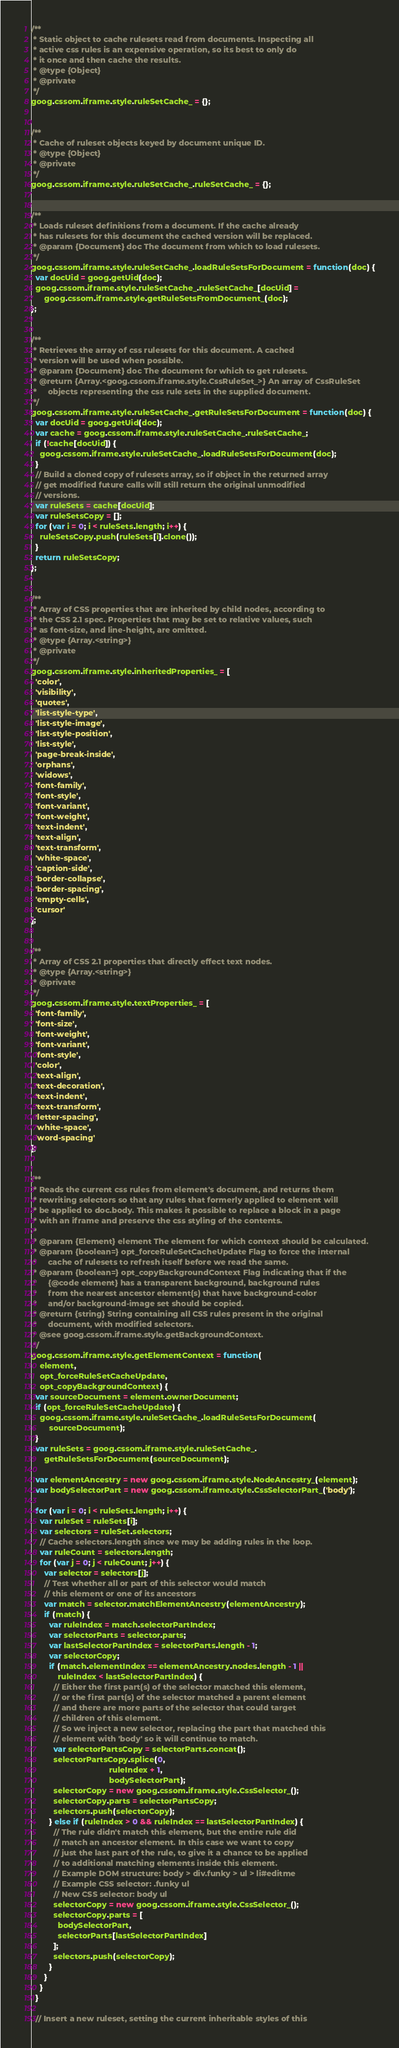<code> <loc_0><loc_0><loc_500><loc_500><_JavaScript_>
/**
 * Static object to cache rulesets read from documents. Inspecting all
 * active css rules is an expensive operation, so its best to only do
 * it once and then cache the results.
 * @type {Object}
 * @private
 */
goog.cssom.iframe.style.ruleSetCache_ = {};


/**
 * Cache of ruleset objects keyed by document unique ID.
 * @type {Object}
 * @private
 */
goog.cssom.iframe.style.ruleSetCache_.ruleSetCache_ = {};


/**
 * Loads ruleset definitions from a document. If the cache already
 * has rulesets for this document the cached version will be replaced.
 * @param {Document} doc The document from which to load rulesets.
 */
goog.cssom.iframe.style.ruleSetCache_.loadRuleSetsForDocument = function(doc) {
  var docUid = goog.getUid(doc);
  goog.cssom.iframe.style.ruleSetCache_.ruleSetCache_[docUid] =
      goog.cssom.iframe.style.getRuleSetsFromDocument_(doc);
};


/**
 * Retrieves the array of css rulesets for this document. A cached
 * version will be used when possible.
 * @param {Document} doc The document for which to get rulesets.
 * @return {Array.<goog.cssom.iframe.style.CssRuleSet_>} An array of CssRuleSet
 *     objects representing the css rule sets in the supplied document.
 */
goog.cssom.iframe.style.ruleSetCache_.getRuleSetsForDocument = function(doc) {
  var docUid = goog.getUid(doc);
  var cache = goog.cssom.iframe.style.ruleSetCache_.ruleSetCache_;
  if (!cache[docUid]) {
    goog.cssom.iframe.style.ruleSetCache_.loadRuleSetsForDocument(doc);
  }
  // Build a cloned copy of rulesets array, so if object in the returned array
  // get modified future calls will still return the original unmodified
  // versions.
  var ruleSets = cache[docUid];
  var ruleSetsCopy = [];
  for (var i = 0; i < ruleSets.length; i++) {
    ruleSetsCopy.push(ruleSets[i].clone());
  }
  return ruleSetsCopy;
};


/**
 * Array of CSS properties that are inherited by child nodes, according to
 * the CSS 2.1 spec. Properties that may be set to relative values, such
 * as font-size, and line-height, are omitted.
 * @type {Array.<string>}
 * @private
 */
goog.cssom.iframe.style.inheritedProperties_ = [
  'color',
  'visibility',
  'quotes',
  'list-style-type',
  'list-style-image',
  'list-style-position',
  'list-style',
  'page-break-inside',
  'orphans',
  'widows',
  'font-family',
  'font-style',
  'font-variant',
  'font-weight',
  'text-indent',
  'text-align',
  'text-transform',
  'white-space',
  'caption-side',
  'border-collapse',
  'border-spacing',
  'empty-cells',
  'cursor'
];


/**
 * Array of CSS 2.1 properties that directly effect text nodes.
 * @type {Array.<string>}
 * @private
 */
goog.cssom.iframe.style.textProperties_ = [
  'font-family',
  'font-size',
  'font-weight',
  'font-variant',
  'font-style',
  'color',
  'text-align',
  'text-decoration',
  'text-indent',
  'text-transform',
  'letter-spacing',
  'white-space',
  'word-spacing'
];


/**
 * Reads the current css rules from element's document, and returns them
 * rewriting selectors so that any rules that formerly applied to element will
 * be applied to doc.body. This makes it possible to replace a block in a page
 * with an iframe and preserve the css styling of the contents.
 *
 * @param {Element} element The element for which context should be calculated.
 * @param {boolean=} opt_forceRuleSetCacheUpdate Flag to force the internal
 *     cache of rulesets to refresh itself before we read the same.
 * @param {boolean=} opt_copyBackgroundContext Flag indicating that if the
 *     {@code element} has a transparent background, background rules
 *     from the nearest ancestor element(s) that have background-color
 *     and/or background-image set should be copied.
 * @return {string} String containing all CSS rules present in the original
 *     document, with modified selectors.
 * @see goog.cssom.iframe.style.getBackgroundContext.
 */
goog.cssom.iframe.style.getElementContext = function(
    element,
    opt_forceRuleSetCacheUpdate,
    opt_copyBackgroundContext) {
  var sourceDocument = element.ownerDocument;
  if (opt_forceRuleSetCacheUpdate) {
    goog.cssom.iframe.style.ruleSetCache_.loadRuleSetsForDocument(
        sourceDocument);
  }
  var ruleSets = goog.cssom.iframe.style.ruleSetCache_.
      getRuleSetsForDocument(sourceDocument);

  var elementAncestry = new goog.cssom.iframe.style.NodeAncestry_(element);
  var bodySelectorPart = new goog.cssom.iframe.style.CssSelectorPart_('body');

  for (var i = 0; i < ruleSets.length; i++) {
    var ruleSet = ruleSets[i];
    var selectors = ruleSet.selectors;
    // Cache selectors.length since we may be adding rules in the loop.
    var ruleCount = selectors.length;
    for (var j = 0; j < ruleCount; j++) {
      var selector = selectors[j];
      // Test whether all or part of this selector would match
      // this element or one of its ancestors
      var match = selector.matchElementAncestry(elementAncestry);
      if (match) {
        var ruleIndex = match.selectorPartIndex;
        var selectorParts = selector.parts;
        var lastSelectorPartIndex = selectorParts.length - 1;
        var selectorCopy;
        if (match.elementIndex == elementAncestry.nodes.length - 1 ||
            ruleIndex < lastSelectorPartIndex) {
          // Either the first part(s) of the selector matched this element,
          // or the first part(s) of the selector matched a parent element
          // and there are more parts of the selector that could target
          // children of this element.
          // So we inject a new selector, replacing the part that matched this
          // element with 'body' so it will continue to match.
          var selectorPartsCopy = selectorParts.concat();
          selectorPartsCopy.splice(0,
                                   ruleIndex + 1,
                                   bodySelectorPart);
          selectorCopy = new goog.cssom.iframe.style.CssSelector_();
          selectorCopy.parts = selectorPartsCopy;
          selectors.push(selectorCopy);
        } else if (ruleIndex > 0 && ruleIndex == lastSelectorPartIndex) {
          // The rule didn't match this element, but the entire rule did
          // match an ancestor element. In this case we want to copy
          // just the last part of the rule, to give it a chance to be applied
          // to additional matching elements inside this element.
          // Example DOM structure: body > div.funky > ul > li#editme
          // Example CSS selector: .funky ul
          // New CSS selector: body ul
          selectorCopy = new goog.cssom.iframe.style.CssSelector_();
          selectorCopy.parts = [
            bodySelectorPart,
            selectorParts[lastSelectorPartIndex]
          ];
          selectors.push(selectorCopy);
        }
      }
    }
  }

  // Insert a new ruleset, setting the current inheritable styles of this</code> 